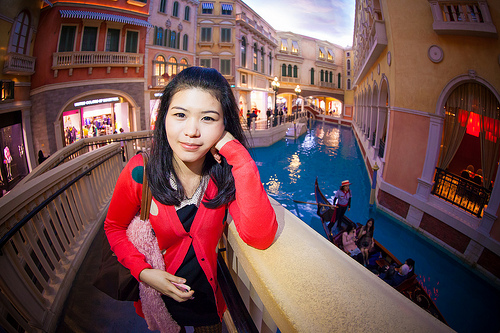<image>
Is there a person in front of the boat? Yes. The person is positioned in front of the boat, appearing closer to the camera viewpoint. 